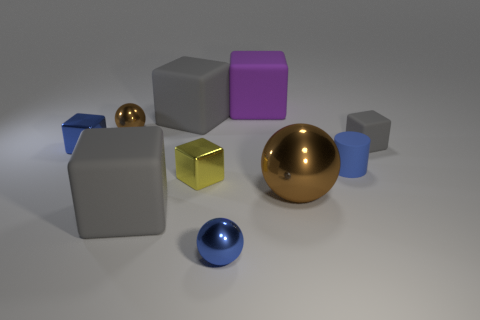How many brown balls must be subtracted to get 1 brown balls? 1 Subtract all brown balls. How many gray cubes are left? 3 Subtract all blue metallic balls. How many balls are left? 2 Subtract all purple cubes. How many cubes are left? 5 Subtract all brown cubes. Subtract all green balls. How many cubes are left? 6 Subtract 0 brown cylinders. How many objects are left? 10 Subtract all cylinders. How many objects are left? 9 Subtract all big yellow matte cubes. Subtract all tiny brown metallic objects. How many objects are left? 9 Add 5 small yellow metal things. How many small yellow metal things are left? 6 Add 5 small gray matte cylinders. How many small gray matte cylinders exist? 5 